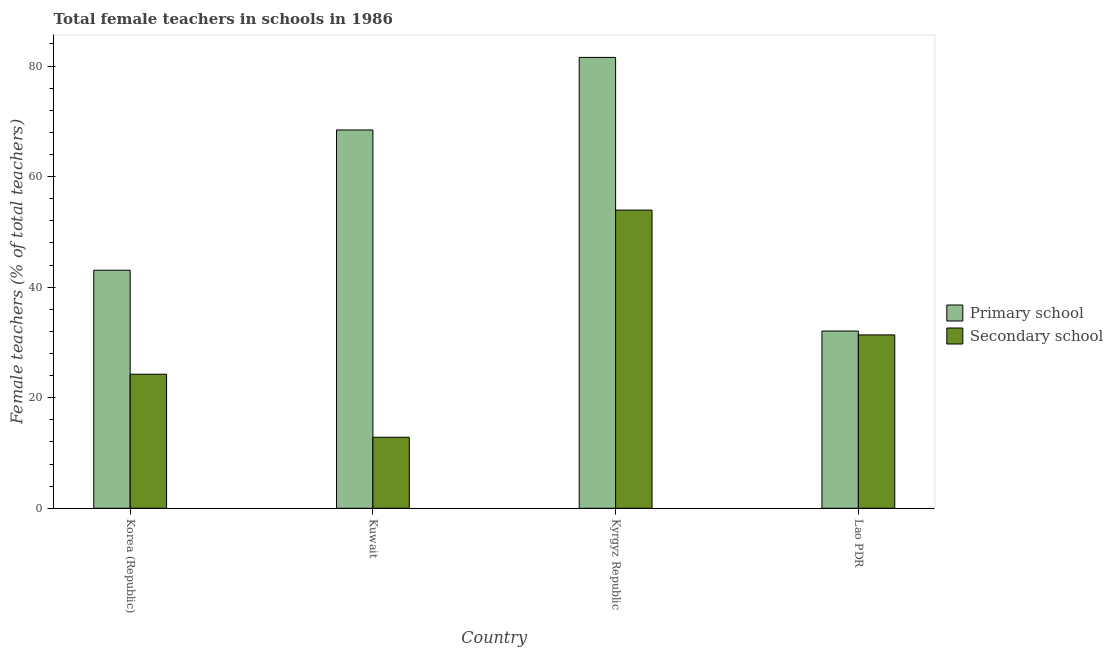How many different coloured bars are there?
Your answer should be very brief. 2. How many groups of bars are there?
Provide a succinct answer. 4. Are the number of bars on each tick of the X-axis equal?
Ensure brevity in your answer.  Yes. How many bars are there on the 1st tick from the right?
Make the answer very short. 2. What is the label of the 1st group of bars from the left?
Your answer should be very brief. Korea (Republic). What is the percentage of female teachers in secondary schools in Kyrgyz Republic?
Offer a very short reply. 53.94. Across all countries, what is the maximum percentage of female teachers in primary schools?
Your answer should be very brief. 81.56. Across all countries, what is the minimum percentage of female teachers in primary schools?
Provide a short and direct response. 32.06. In which country was the percentage of female teachers in primary schools maximum?
Provide a succinct answer. Kyrgyz Republic. In which country was the percentage of female teachers in secondary schools minimum?
Your answer should be compact. Kuwait. What is the total percentage of female teachers in secondary schools in the graph?
Keep it short and to the point. 122.41. What is the difference between the percentage of female teachers in secondary schools in Kuwait and that in Kyrgyz Republic?
Keep it short and to the point. -41.09. What is the difference between the percentage of female teachers in secondary schools in Kyrgyz Republic and the percentage of female teachers in primary schools in Kuwait?
Keep it short and to the point. -14.5. What is the average percentage of female teachers in secondary schools per country?
Keep it short and to the point. 30.6. What is the difference between the percentage of female teachers in secondary schools and percentage of female teachers in primary schools in Korea (Republic)?
Give a very brief answer. -18.81. What is the ratio of the percentage of female teachers in primary schools in Korea (Republic) to that in Kuwait?
Offer a terse response. 0.63. Is the percentage of female teachers in secondary schools in Korea (Republic) less than that in Lao PDR?
Your response must be concise. Yes. Is the difference between the percentage of female teachers in primary schools in Kyrgyz Republic and Lao PDR greater than the difference between the percentage of female teachers in secondary schools in Kyrgyz Republic and Lao PDR?
Ensure brevity in your answer.  Yes. What is the difference between the highest and the second highest percentage of female teachers in secondary schools?
Keep it short and to the point. 22.58. What is the difference between the highest and the lowest percentage of female teachers in primary schools?
Offer a very short reply. 49.5. In how many countries, is the percentage of female teachers in primary schools greater than the average percentage of female teachers in primary schools taken over all countries?
Provide a succinct answer. 2. Is the sum of the percentage of female teachers in secondary schools in Korea (Republic) and Kuwait greater than the maximum percentage of female teachers in primary schools across all countries?
Your answer should be very brief. No. What does the 1st bar from the left in Kuwait represents?
Make the answer very short. Primary school. What does the 1st bar from the right in Kyrgyz Republic represents?
Provide a short and direct response. Secondary school. Does the graph contain any zero values?
Give a very brief answer. No. How many legend labels are there?
Your answer should be compact. 2. What is the title of the graph?
Your answer should be compact. Total female teachers in schools in 1986. Does "Fraud firms" appear as one of the legend labels in the graph?
Your answer should be compact. No. What is the label or title of the Y-axis?
Your answer should be very brief. Female teachers (% of total teachers). What is the Female teachers (% of total teachers) of Primary school in Korea (Republic)?
Keep it short and to the point. 43.07. What is the Female teachers (% of total teachers) of Secondary school in Korea (Republic)?
Offer a terse response. 24.25. What is the Female teachers (% of total teachers) of Primary school in Kuwait?
Provide a short and direct response. 68.44. What is the Female teachers (% of total teachers) in Secondary school in Kuwait?
Give a very brief answer. 12.85. What is the Female teachers (% of total teachers) in Primary school in Kyrgyz Republic?
Your answer should be compact. 81.56. What is the Female teachers (% of total teachers) in Secondary school in Kyrgyz Republic?
Offer a very short reply. 53.94. What is the Female teachers (% of total teachers) in Primary school in Lao PDR?
Ensure brevity in your answer.  32.06. What is the Female teachers (% of total teachers) of Secondary school in Lao PDR?
Your response must be concise. 31.36. Across all countries, what is the maximum Female teachers (% of total teachers) in Primary school?
Give a very brief answer. 81.56. Across all countries, what is the maximum Female teachers (% of total teachers) of Secondary school?
Provide a succinct answer. 53.94. Across all countries, what is the minimum Female teachers (% of total teachers) in Primary school?
Ensure brevity in your answer.  32.06. Across all countries, what is the minimum Female teachers (% of total teachers) in Secondary school?
Provide a short and direct response. 12.85. What is the total Female teachers (% of total teachers) in Primary school in the graph?
Provide a short and direct response. 225.13. What is the total Female teachers (% of total teachers) of Secondary school in the graph?
Offer a terse response. 122.41. What is the difference between the Female teachers (% of total teachers) of Primary school in Korea (Republic) and that in Kuwait?
Keep it short and to the point. -25.38. What is the difference between the Female teachers (% of total teachers) in Secondary school in Korea (Republic) and that in Kuwait?
Provide a succinct answer. 11.4. What is the difference between the Female teachers (% of total teachers) in Primary school in Korea (Republic) and that in Kyrgyz Republic?
Keep it short and to the point. -38.5. What is the difference between the Female teachers (% of total teachers) in Secondary school in Korea (Republic) and that in Kyrgyz Republic?
Your response must be concise. -29.69. What is the difference between the Female teachers (% of total teachers) of Primary school in Korea (Republic) and that in Lao PDR?
Your answer should be compact. 11. What is the difference between the Female teachers (% of total teachers) in Secondary school in Korea (Republic) and that in Lao PDR?
Ensure brevity in your answer.  -7.11. What is the difference between the Female teachers (% of total teachers) of Primary school in Kuwait and that in Kyrgyz Republic?
Give a very brief answer. -13.12. What is the difference between the Female teachers (% of total teachers) in Secondary school in Kuwait and that in Kyrgyz Republic?
Ensure brevity in your answer.  -41.09. What is the difference between the Female teachers (% of total teachers) of Primary school in Kuwait and that in Lao PDR?
Make the answer very short. 36.38. What is the difference between the Female teachers (% of total teachers) in Secondary school in Kuwait and that in Lao PDR?
Give a very brief answer. -18.52. What is the difference between the Female teachers (% of total teachers) in Primary school in Kyrgyz Republic and that in Lao PDR?
Give a very brief answer. 49.5. What is the difference between the Female teachers (% of total teachers) in Secondary school in Kyrgyz Republic and that in Lao PDR?
Provide a short and direct response. 22.58. What is the difference between the Female teachers (% of total teachers) in Primary school in Korea (Republic) and the Female teachers (% of total teachers) in Secondary school in Kuwait?
Make the answer very short. 30.22. What is the difference between the Female teachers (% of total teachers) in Primary school in Korea (Republic) and the Female teachers (% of total teachers) in Secondary school in Kyrgyz Republic?
Provide a short and direct response. -10.88. What is the difference between the Female teachers (% of total teachers) in Primary school in Korea (Republic) and the Female teachers (% of total teachers) in Secondary school in Lao PDR?
Your answer should be compact. 11.7. What is the difference between the Female teachers (% of total teachers) of Primary school in Kuwait and the Female teachers (% of total teachers) of Secondary school in Kyrgyz Republic?
Your answer should be compact. 14.5. What is the difference between the Female teachers (% of total teachers) in Primary school in Kuwait and the Female teachers (% of total teachers) in Secondary school in Lao PDR?
Ensure brevity in your answer.  37.08. What is the difference between the Female teachers (% of total teachers) of Primary school in Kyrgyz Republic and the Female teachers (% of total teachers) of Secondary school in Lao PDR?
Ensure brevity in your answer.  50.2. What is the average Female teachers (% of total teachers) of Primary school per country?
Keep it short and to the point. 56.28. What is the average Female teachers (% of total teachers) in Secondary school per country?
Your answer should be compact. 30.6. What is the difference between the Female teachers (% of total teachers) in Primary school and Female teachers (% of total teachers) in Secondary school in Korea (Republic)?
Make the answer very short. 18.81. What is the difference between the Female teachers (% of total teachers) of Primary school and Female teachers (% of total teachers) of Secondary school in Kuwait?
Provide a succinct answer. 55.59. What is the difference between the Female teachers (% of total teachers) in Primary school and Female teachers (% of total teachers) in Secondary school in Kyrgyz Republic?
Provide a short and direct response. 27.62. What is the difference between the Female teachers (% of total teachers) of Primary school and Female teachers (% of total teachers) of Secondary school in Lao PDR?
Your answer should be compact. 0.7. What is the ratio of the Female teachers (% of total teachers) in Primary school in Korea (Republic) to that in Kuwait?
Give a very brief answer. 0.63. What is the ratio of the Female teachers (% of total teachers) in Secondary school in Korea (Republic) to that in Kuwait?
Ensure brevity in your answer.  1.89. What is the ratio of the Female teachers (% of total teachers) in Primary school in Korea (Republic) to that in Kyrgyz Republic?
Your answer should be very brief. 0.53. What is the ratio of the Female teachers (% of total teachers) of Secondary school in Korea (Republic) to that in Kyrgyz Republic?
Provide a succinct answer. 0.45. What is the ratio of the Female teachers (% of total teachers) in Primary school in Korea (Republic) to that in Lao PDR?
Keep it short and to the point. 1.34. What is the ratio of the Female teachers (% of total teachers) in Secondary school in Korea (Republic) to that in Lao PDR?
Your response must be concise. 0.77. What is the ratio of the Female teachers (% of total teachers) of Primary school in Kuwait to that in Kyrgyz Republic?
Give a very brief answer. 0.84. What is the ratio of the Female teachers (% of total teachers) in Secondary school in Kuwait to that in Kyrgyz Republic?
Your answer should be compact. 0.24. What is the ratio of the Female teachers (% of total teachers) of Primary school in Kuwait to that in Lao PDR?
Your answer should be compact. 2.13. What is the ratio of the Female teachers (% of total teachers) of Secondary school in Kuwait to that in Lao PDR?
Provide a short and direct response. 0.41. What is the ratio of the Female teachers (% of total teachers) in Primary school in Kyrgyz Republic to that in Lao PDR?
Provide a short and direct response. 2.54. What is the ratio of the Female teachers (% of total teachers) of Secondary school in Kyrgyz Republic to that in Lao PDR?
Your response must be concise. 1.72. What is the difference between the highest and the second highest Female teachers (% of total teachers) in Primary school?
Offer a terse response. 13.12. What is the difference between the highest and the second highest Female teachers (% of total teachers) in Secondary school?
Your answer should be very brief. 22.58. What is the difference between the highest and the lowest Female teachers (% of total teachers) of Primary school?
Make the answer very short. 49.5. What is the difference between the highest and the lowest Female teachers (% of total teachers) of Secondary school?
Provide a succinct answer. 41.09. 